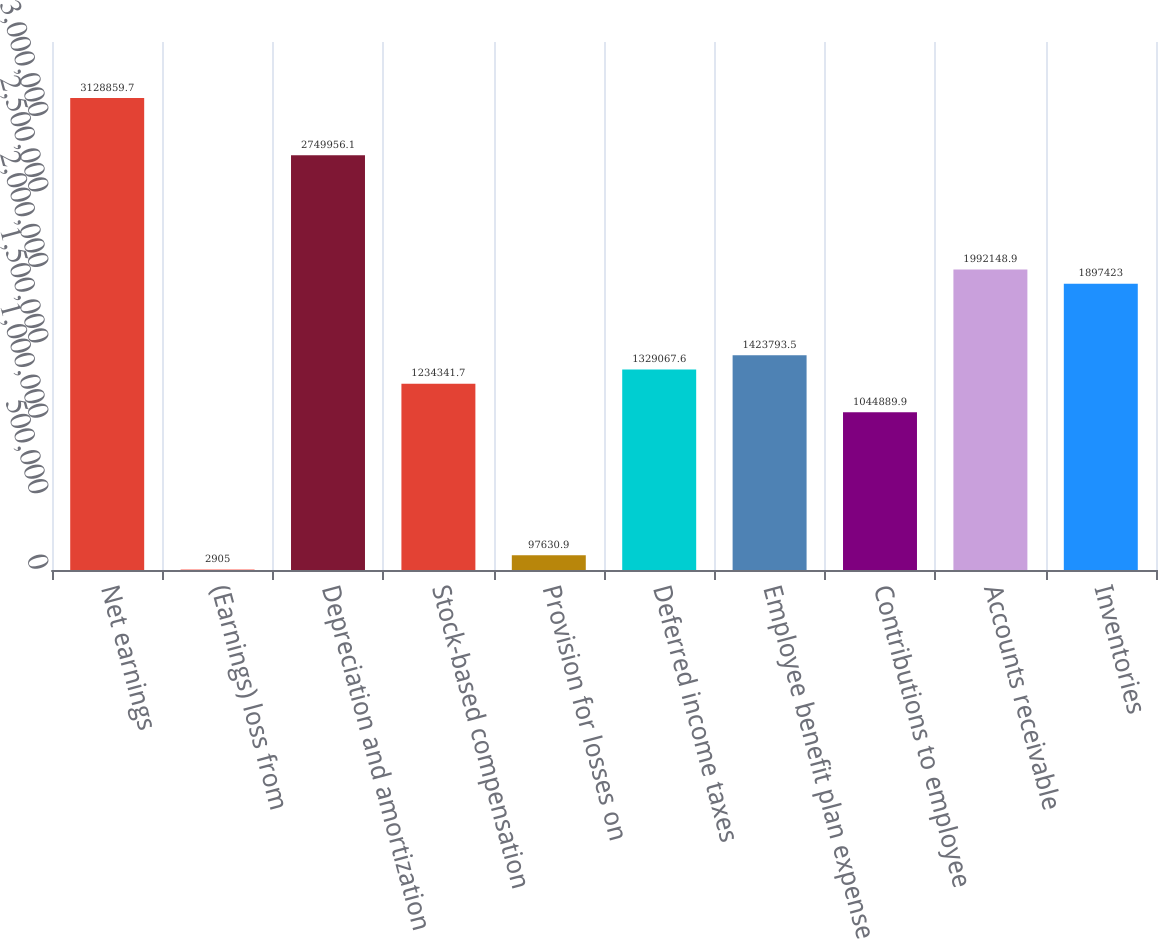Convert chart. <chart><loc_0><loc_0><loc_500><loc_500><bar_chart><fcel>Net earnings<fcel>(Earnings) loss from<fcel>Depreciation and amortization<fcel>Stock-based compensation<fcel>Provision for losses on<fcel>Deferred income taxes<fcel>Employee benefit plan expense<fcel>Contributions to employee<fcel>Accounts receivable<fcel>Inventories<nl><fcel>3.12886e+06<fcel>2905<fcel>2.74996e+06<fcel>1.23434e+06<fcel>97630.9<fcel>1.32907e+06<fcel>1.42379e+06<fcel>1.04489e+06<fcel>1.99215e+06<fcel>1.89742e+06<nl></chart> 